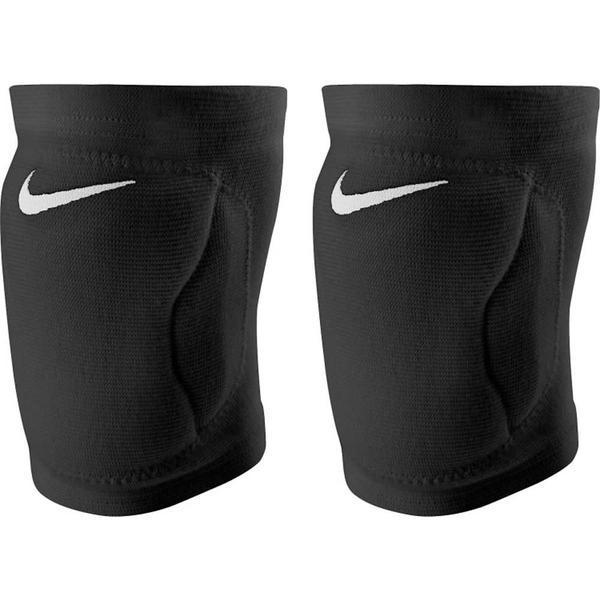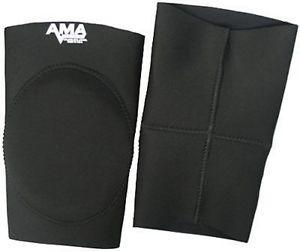The first image is the image on the left, the second image is the image on the right. Considering the images on both sides, is "There are two kneepads in total" valid? Answer yes or no. No. 